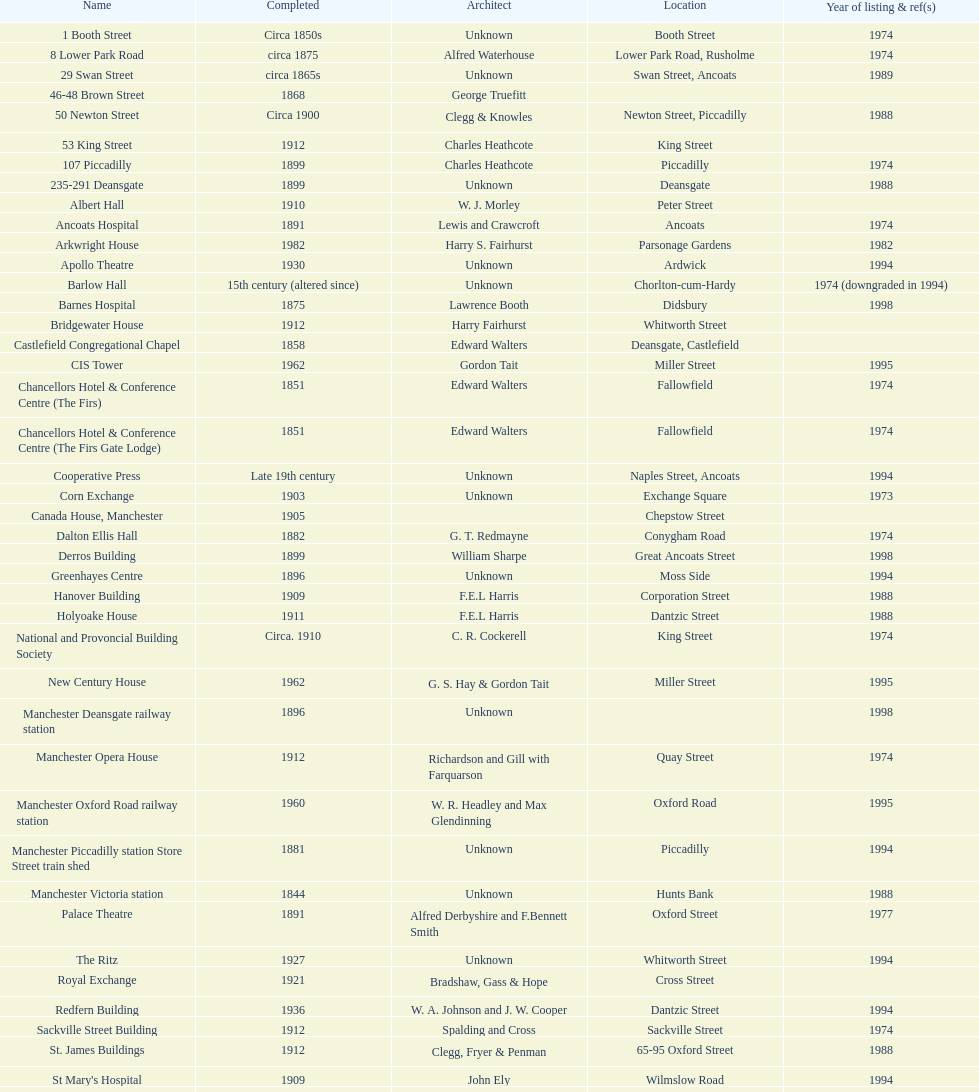Which two structures were catalogued prior to 1974? The Old Wellington Inn, Smithfield Market Hall. 